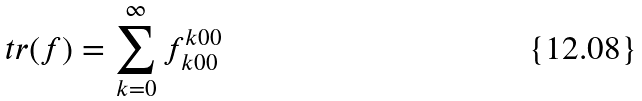<formula> <loc_0><loc_0><loc_500><loc_500>t r ( f ) = \sum _ { k = 0 } ^ { \infty } f _ { k 0 0 } ^ { k 0 0 }</formula> 